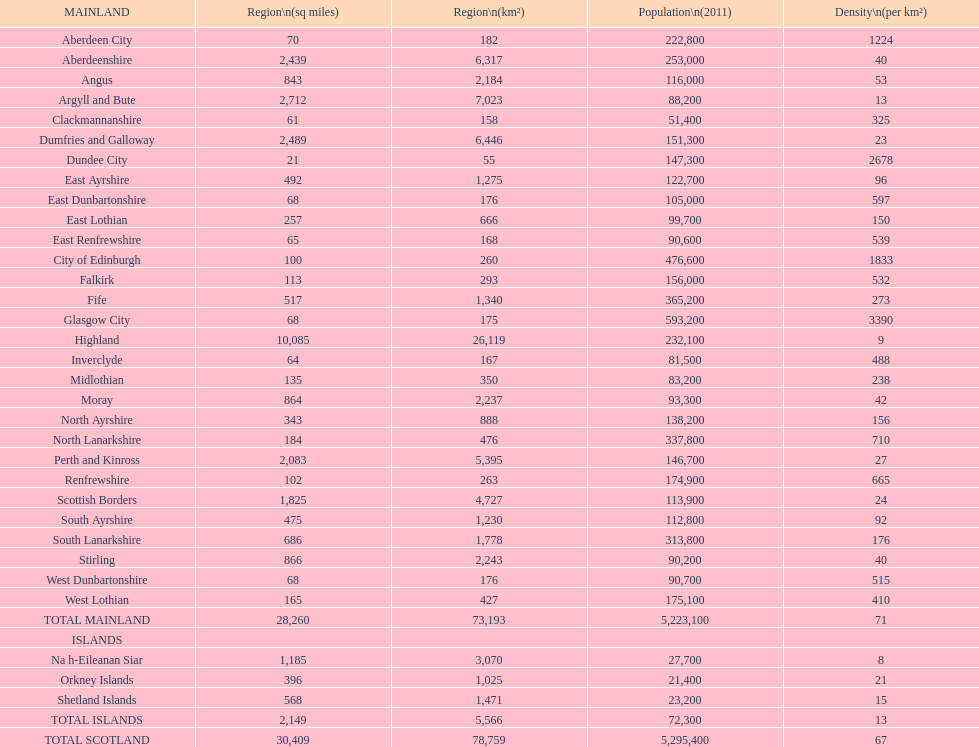What is the difference in square miles from angus and fife? 326. Could you parse the entire table? {'header': ['MAINLAND', 'Region\\n(sq miles)', 'Region\\n(km²)', 'Population\\n(2011)', 'Density\\n(per km²)'], 'rows': [['Aberdeen City', '70', '182', '222,800', '1224'], ['Aberdeenshire', '2,439', '6,317', '253,000', '40'], ['Angus', '843', '2,184', '116,000', '53'], ['Argyll and Bute', '2,712', '7,023', '88,200', '13'], ['Clackmannanshire', '61', '158', '51,400', '325'], ['Dumfries and Galloway', '2,489', '6,446', '151,300', '23'], ['Dundee City', '21', '55', '147,300', '2678'], ['East Ayrshire', '492', '1,275', '122,700', '96'], ['East Dunbartonshire', '68', '176', '105,000', '597'], ['East Lothian', '257', '666', '99,700', '150'], ['East Renfrewshire', '65', '168', '90,600', '539'], ['City of Edinburgh', '100', '260', '476,600', '1833'], ['Falkirk', '113', '293', '156,000', '532'], ['Fife', '517', '1,340', '365,200', '273'], ['Glasgow City', '68', '175', '593,200', '3390'], ['Highland', '10,085', '26,119', '232,100', '9'], ['Inverclyde', '64', '167', '81,500', '488'], ['Midlothian', '135', '350', '83,200', '238'], ['Moray', '864', '2,237', '93,300', '42'], ['North Ayrshire', '343', '888', '138,200', '156'], ['North Lanarkshire', '184', '476', '337,800', '710'], ['Perth and Kinross', '2,083', '5,395', '146,700', '27'], ['Renfrewshire', '102', '263', '174,900', '665'], ['Scottish Borders', '1,825', '4,727', '113,900', '24'], ['South Ayrshire', '475', '1,230', '112,800', '92'], ['South Lanarkshire', '686', '1,778', '313,800', '176'], ['Stirling', '866', '2,243', '90,200', '40'], ['West Dunbartonshire', '68', '176', '90,700', '515'], ['West Lothian', '165', '427', '175,100', '410'], ['TOTAL MAINLAND', '28,260', '73,193', '5,223,100', '71'], ['ISLANDS', '', '', '', ''], ['Na h-Eileanan Siar', '1,185', '3,070', '27,700', '8'], ['Orkney Islands', '396', '1,025', '21,400', '21'], ['Shetland Islands', '568', '1,471', '23,200', '15'], ['TOTAL ISLANDS', '2,149', '5,566', '72,300', '13'], ['TOTAL SCOTLAND', '30,409', '78,759', '5,295,400', '67']]} 